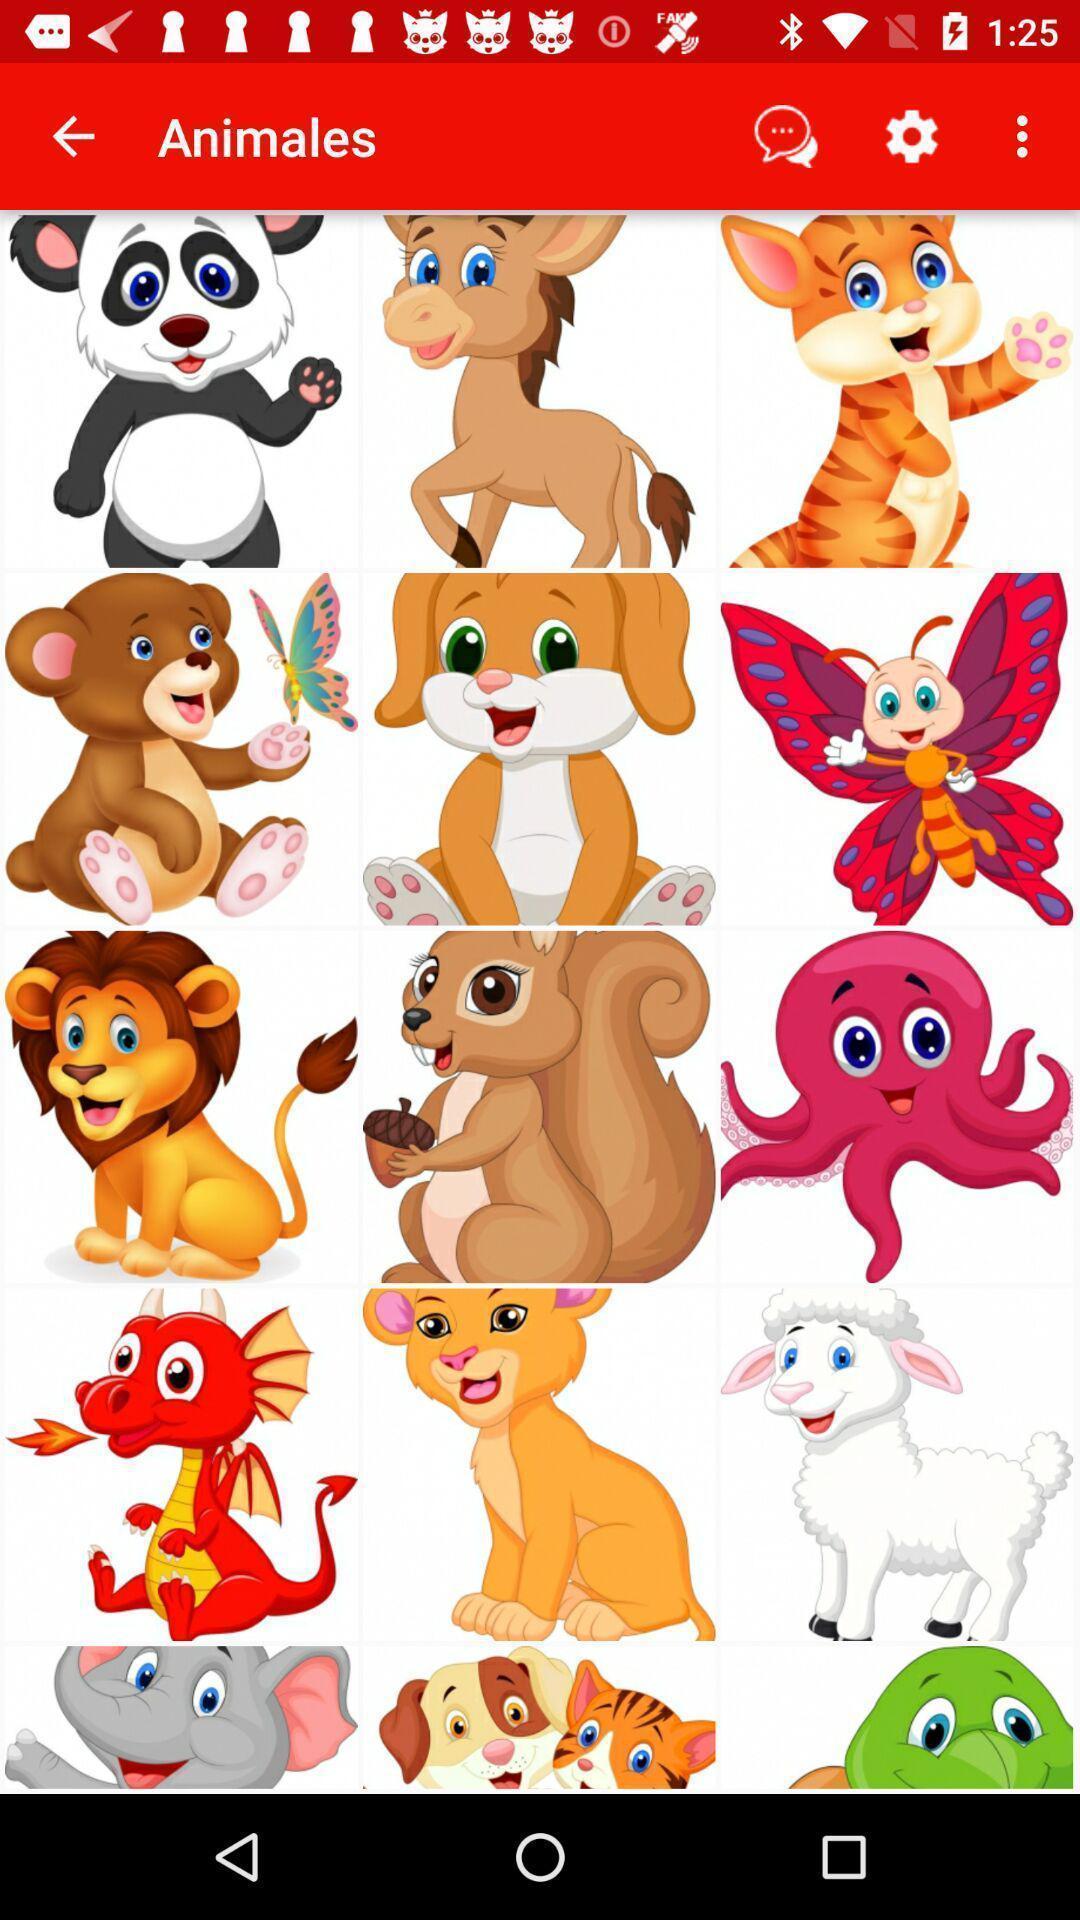Describe the visual elements of this screenshot. Screen shows multiple stickers. 